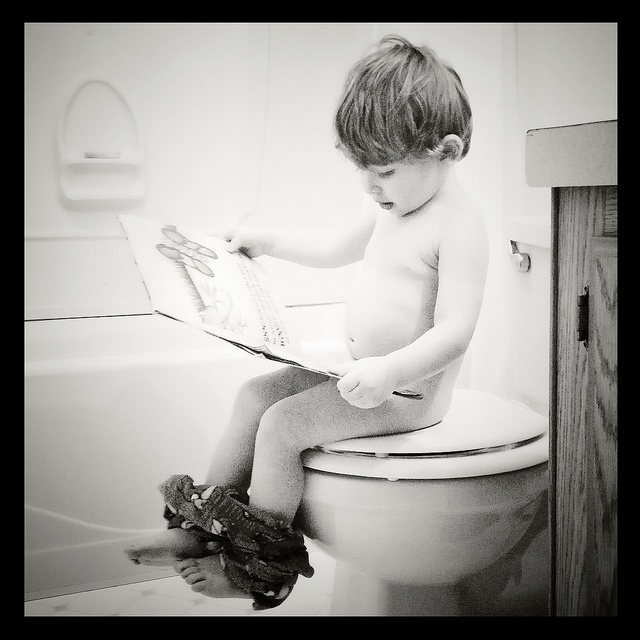Describe the objects in this image and their specific colors. I can see people in black, lightgray, darkgray, and gray tones, toilet in black, lightgray, darkgray, and gray tones, and book in black, white, darkgray, gray, and lightgray tones in this image. 